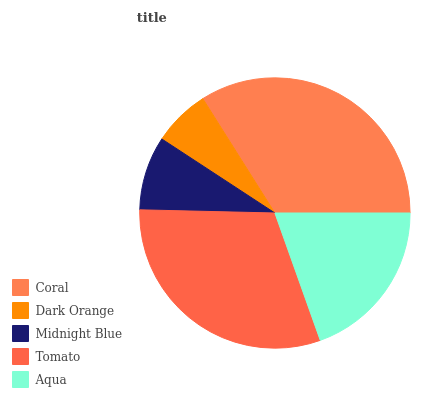Is Dark Orange the minimum?
Answer yes or no. Yes. Is Coral the maximum?
Answer yes or no. Yes. Is Midnight Blue the minimum?
Answer yes or no. No. Is Midnight Blue the maximum?
Answer yes or no. No. Is Midnight Blue greater than Dark Orange?
Answer yes or no. Yes. Is Dark Orange less than Midnight Blue?
Answer yes or no. Yes. Is Dark Orange greater than Midnight Blue?
Answer yes or no. No. Is Midnight Blue less than Dark Orange?
Answer yes or no. No. Is Aqua the high median?
Answer yes or no. Yes. Is Aqua the low median?
Answer yes or no. Yes. Is Tomato the high median?
Answer yes or no. No. Is Tomato the low median?
Answer yes or no. No. 